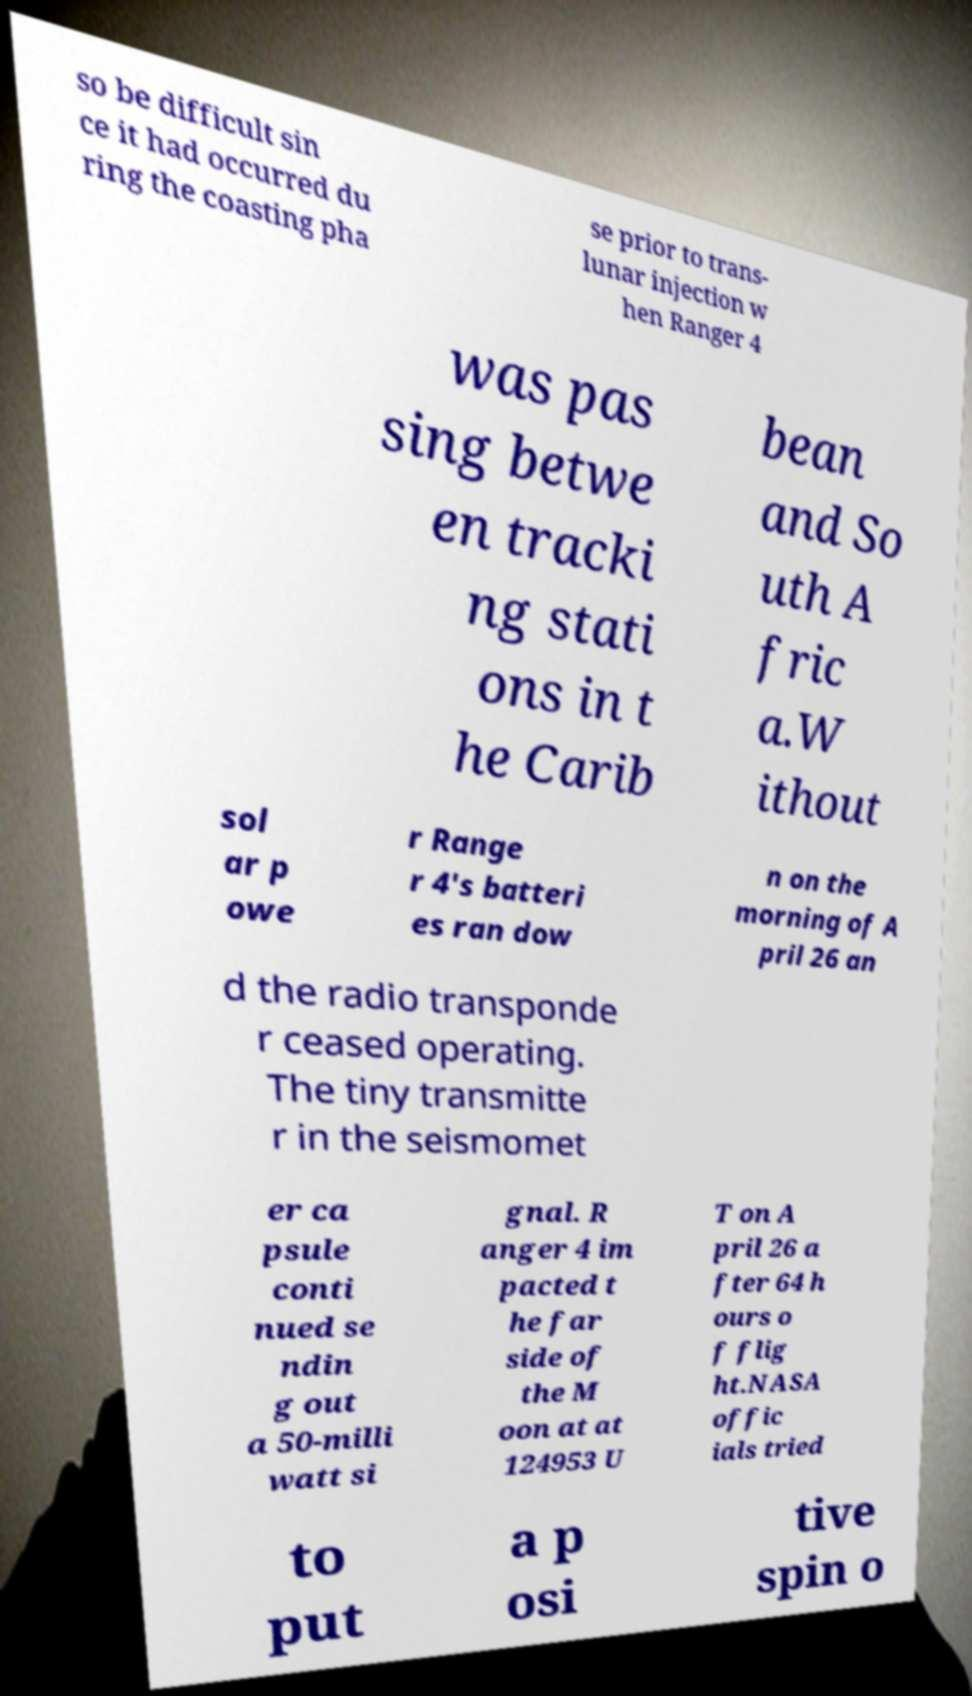I need the written content from this picture converted into text. Can you do that? so be difficult sin ce it had occurred du ring the coasting pha se prior to trans- lunar injection w hen Ranger 4 was pas sing betwe en tracki ng stati ons in t he Carib bean and So uth A fric a.W ithout sol ar p owe r Range r 4's batteri es ran dow n on the morning of A pril 26 an d the radio transponde r ceased operating. The tiny transmitte r in the seismomet er ca psule conti nued se ndin g out a 50-milli watt si gnal. R anger 4 im pacted t he far side of the M oon at at 124953 U T on A pril 26 a fter 64 h ours o f flig ht.NASA offic ials tried to put a p osi tive spin o 